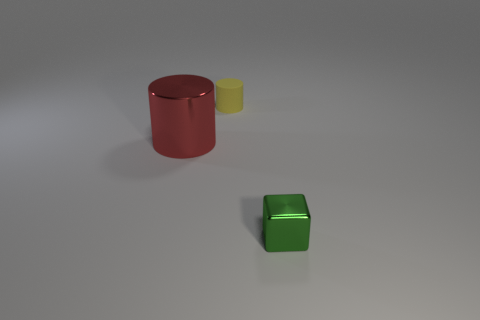Add 1 blue balls. How many objects exist? 4 Subtract all cubes. How many objects are left? 2 Add 1 large yellow metallic balls. How many large yellow metallic balls exist? 1 Subtract 0 blue balls. How many objects are left? 3 Subtract all small blue cylinders. Subtract all rubber cylinders. How many objects are left? 2 Add 3 red things. How many red things are left? 4 